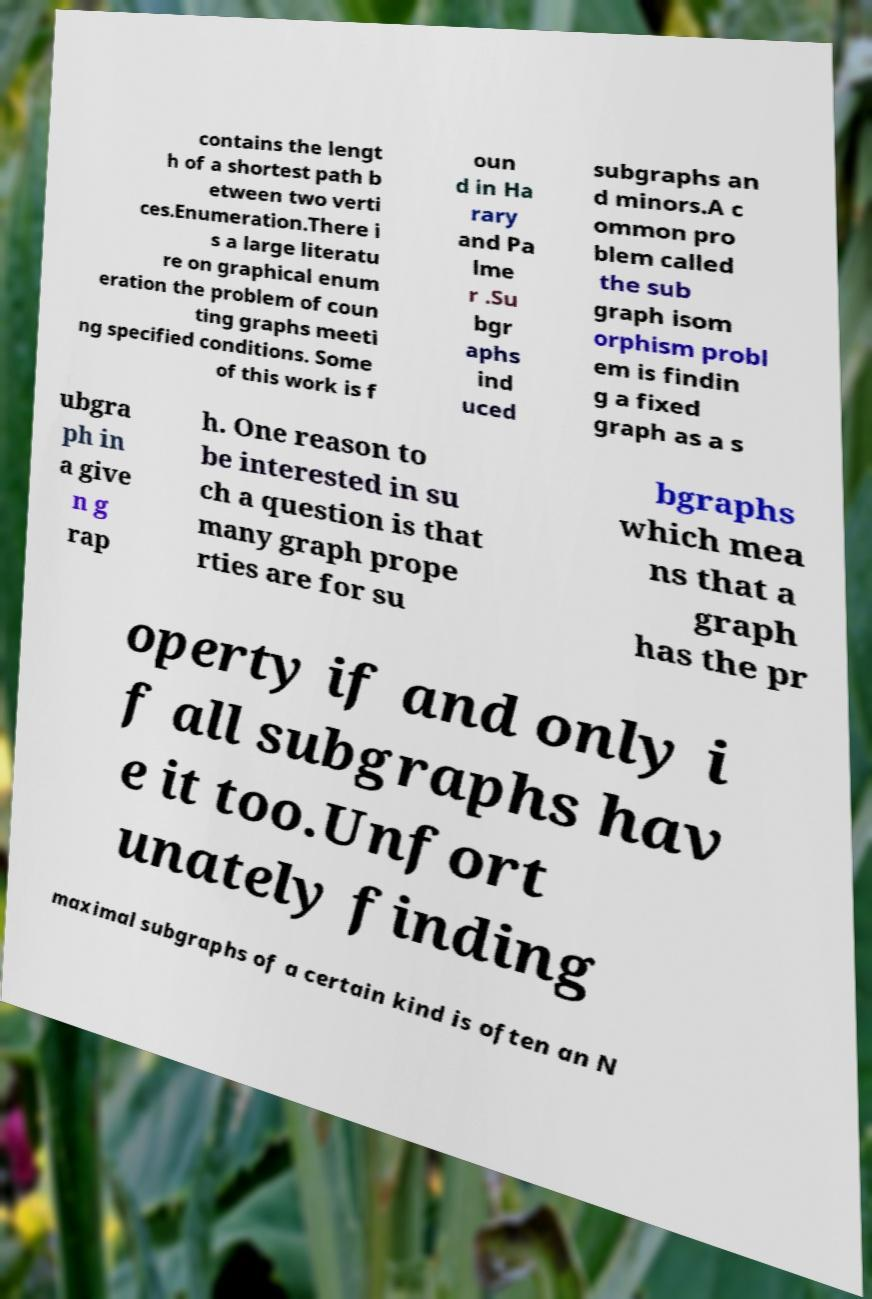Could you assist in decoding the text presented in this image and type it out clearly? contains the lengt h of a shortest path b etween two verti ces.Enumeration.There i s a large literatu re on graphical enum eration the problem of coun ting graphs meeti ng specified conditions. Some of this work is f oun d in Ha rary and Pa lme r .Su bgr aphs ind uced subgraphs an d minors.A c ommon pro blem called the sub graph isom orphism probl em is findin g a fixed graph as a s ubgra ph in a give n g rap h. One reason to be interested in su ch a question is that many graph prope rties are for su bgraphs which mea ns that a graph has the pr operty if and only i f all subgraphs hav e it too.Unfort unately finding maximal subgraphs of a certain kind is often an N 